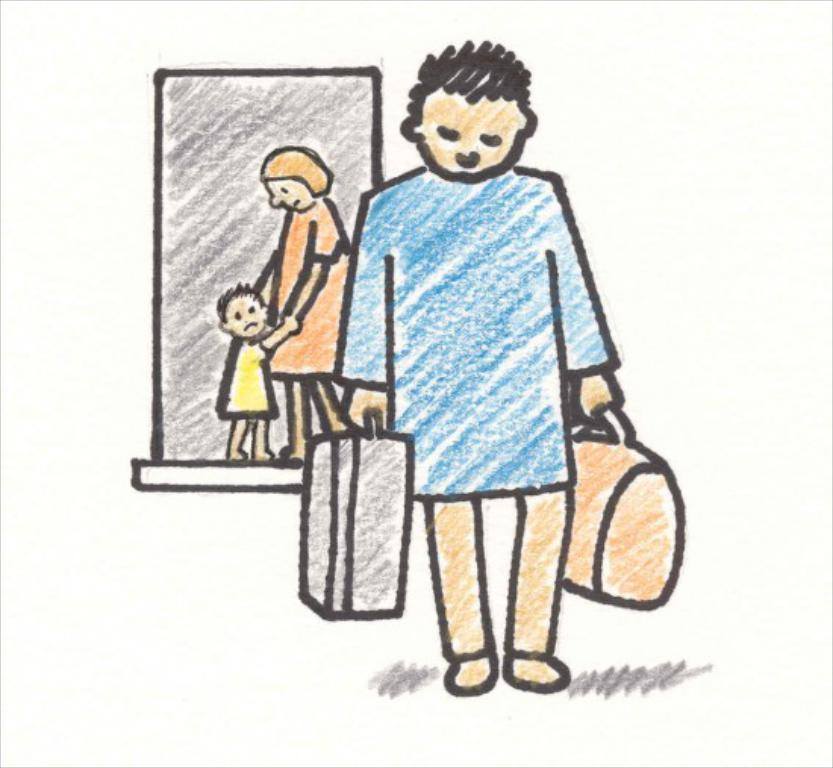What type of artwork is depicted in the image? The image is a painting. What is the main subject of the painting? There is a man standing in the painting. What is the man holding in his hand? The man is holding bags in his hand. Can you describe the background of the painting? There is a lady and a kid in the background of the painting. What architectural feature is visible in the painting? There is a door visible in the painting. What type of scissors can be seen being used by the man in the painting? There are no scissors present in the painting; the man is holding bags in his hand. What flavor of jelly is the kid eating in the background of the painting? There is no jelly or any food visible in the painting; the kid is simply present in the background. 